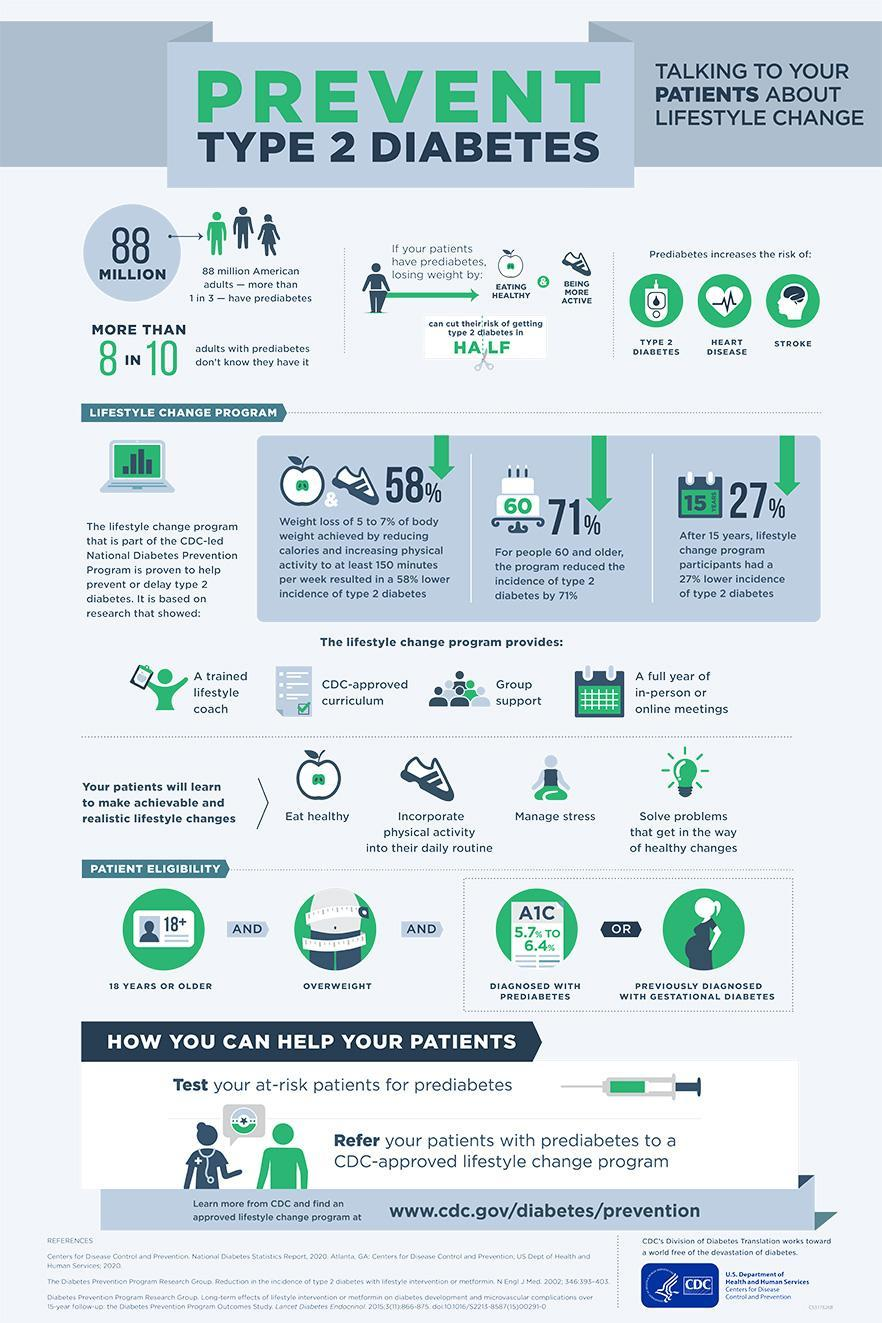What percentage of people can see reduced incidence in type 2 diabetes due to weight loss, 27%, 71% or 58%?
Answer the question with a short phrase. 58% What are the risks posed by prediabetes? Type 2 Diabetes, Heart Disease, Stroke What is the level or range of A1C test if a person has been diagnosed as prediabetic? 5.7% to 6.4% How many changes can a patient make after enrolling into the life style change program? 4 Which two activities helps in controlling weight? Eating Healthy, Being More Active 